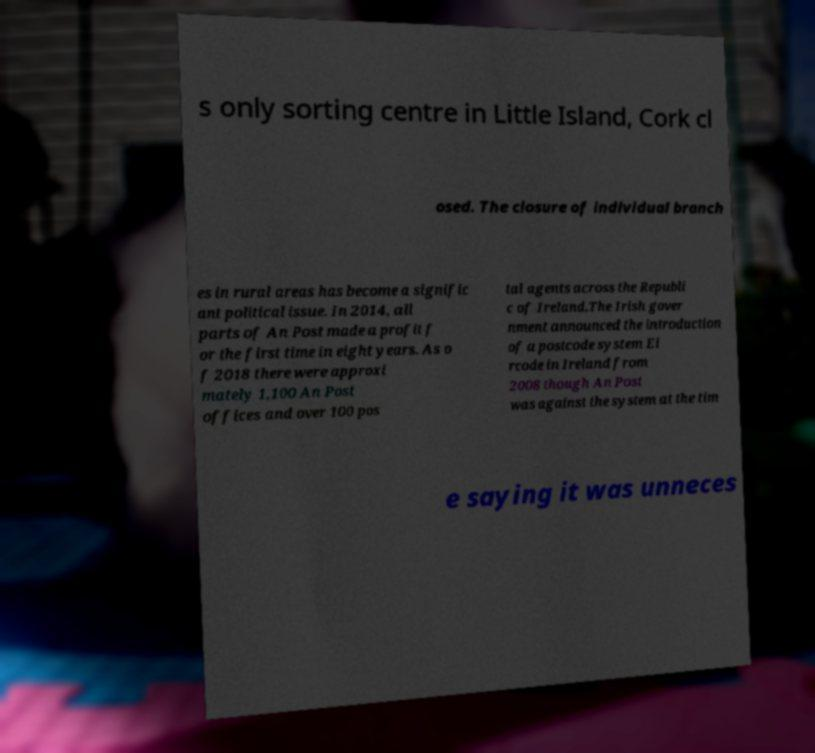I need the written content from this picture converted into text. Can you do that? s only sorting centre in Little Island, Cork cl osed. The closure of individual branch es in rural areas has become a signific ant political issue. In 2014, all parts of An Post made a profit f or the first time in eight years. As o f 2018 there were approxi mately 1,100 An Post offices and over 100 pos tal agents across the Republi c of Ireland.The Irish gover nment announced the introduction of a postcode system Ei rcode in Ireland from 2008 though An Post was against the system at the tim e saying it was unneces 